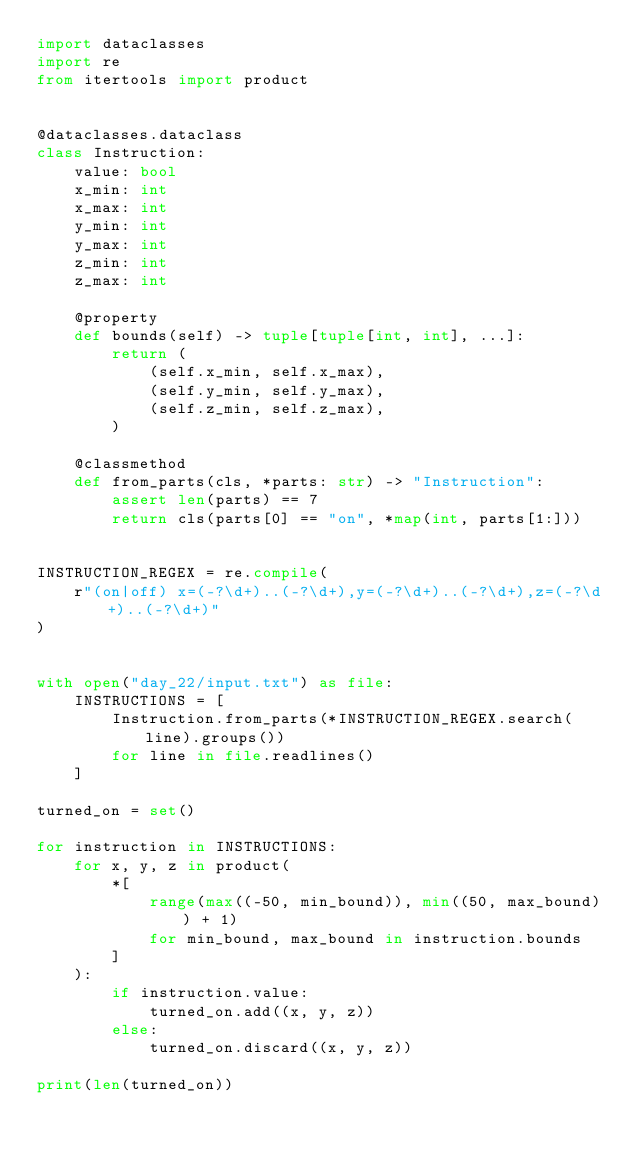Convert code to text. <code><loc_0><loc_0><loc_500><loc_500><_Python_>import dataclasses
import re
from itertools import product


@dataclasses.dataclass
class Instruction:
    value: bool
    x_min: int
    x_max: int
    y_min: int
    y_max: int
    z_min: int
    z_max: int

    @property
    def bounds(self) -> tuple[tuple[int, int], ...]:
        return (
            (self.x_min, self.x_max),
            (self.y_min, self.y_max),
            (self.z_min, self.z_max),
        )

    @classmethod
    def from_parts(cls, *parts: str) -> "Instruction":
        assert len(parts) == 7
        return cls(parts[0] == "on", *map(int, parts[1:]))


INSTRUCTION_REGEX = re.compile(
    r"(on|off) x=(-?\d+)..(-?\d+),y=(-?\d+)..(-?\d+),z=(-?\d+)..(-?\d+)"
)


with open("day_22/input.txt") as file:
    INSTRUCTIONS = [
        Instruction.from_parts(*INSTRUCTION_REGEX.search(line).groups())
        for line in file.readlines()
    ]

turned_on = set()

for instruction in INSTRUCTIONS:
    for x, y, z in product(
        *[
            range(max((-50, min_bound)), min((50, max_bound)) + 1)
            for min_bound, max_bound in instruction.bounds
        ]
    ):
        if instruction.value:
            turned_on.add((x, y, z))
        else:
            turned_on.discard((x, y, z))

print(len(turned_on))
</code> 